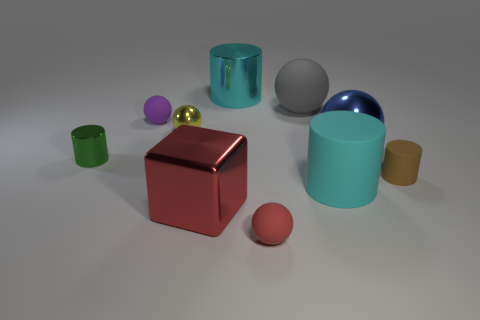How many other things are the same shape as the brown object?
Your answer should be very brief. 3. There is a large matte thing behind the purple sphere; what shape is it?
Ensure brevity in your answer.  Sphere. There is a tiny thing that is on the right side of the matte thing in front of the cyan matte object; what color is it?
Offer a terse response. Brown. What number of objects are large rubber things that are in front of the small metallic cylinder or tiny yellow metallic objects?
Your answer should be compact. 2. There is a blue metallic thing; is it the same size as the cyan cylinder behind the tiny green metal cylinder?
Your answer should be compact. Yes. What number of small objects are purple things or matte cylinders?
Give a very brief answer. 2. What is the shape of the green metallic object?
Ensure brevity in your answer.  Cylinder. What is the size of the object that is the same color as the large block?
Give a very brief answer. Small. Are there any other large things made of the same material as the purple object?
Your answer should be very brief. Yes. Are there more purple matte spheres than large metallic objects?
Provide a short and direct response. No. 